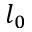<formula> <loc_0><loc_0><loc_500><loc_500>l _ { 0 }</formula> 